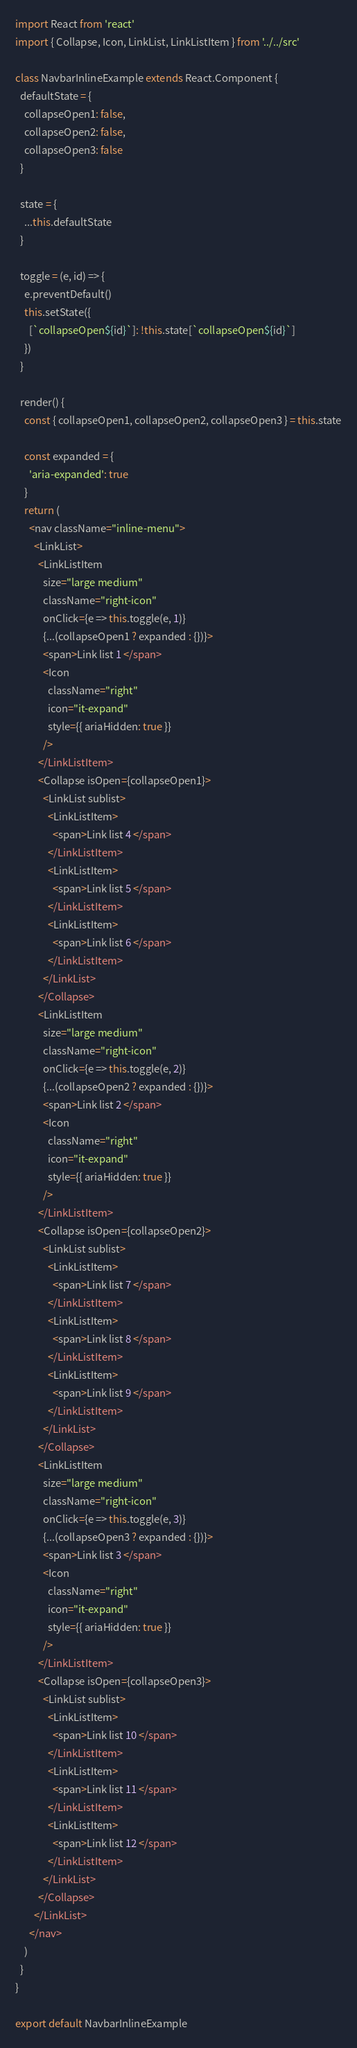Convert code to text. <code><loc_0><loc_0><loc_500><loc_500><_JavaScript_>import React from 'react'
import { Collapse, Icon, LinkList, LinkListItem } from '../../src'

class NavbarInlineExample extends React.Component {
  defaultState = {
    collapseOpen1: false,
    collapseOpen2: false,
    collapseOpen3: false
  }

  state = {
    ...this.defaultState
  }

  toggle = (e, id) => {
    e.preventDefault()
    this.setState({
      [`collapseOpen${id}`]: !this.state[`collapseOpen${id}`]
    })
  }

  render() {
    const { collapseOpen1, collapseOpen2, collapseOpen3 } = this.state

    const expanded = {
      'aria-expanded': true
    }
    return (
      <nav className="inline-menu">
        <LinkList>
          <LinkListItem
            size="large medium"
            className="right-icon"
            onClick={e => this.toggle(e, 1)}
            {...(collapseOpen1 ? expanded : {})}>
            <span>Link list 1 </span>
            <Icon
              className="right"
              icon="it-expand"
              style={{ ariaHidden: true }}
            />
          </LinkListItem>
          <Collapse isOpen={collapseOpen1}>
            <LinkList sublist>
              <LinkListItem>
                <span>Link list 4 </span>
              </LinkListItem>
              <LinkListItem>
                <span>Link list 5 </span>
              </LinkListItem>
              <LinkListItem>
                <span>Link list 6 </span>
              </LinkListItem>
            </LinkList>
          </Collapse>
          <LinkListItem
            size="large medium"
            className="right-icon"
            onClick={e => this.toggle(e, 2)}
            {...(collapseOpen2 ? expanded : {})}>
            <span>Link list 2 </span>
            <Icon
              className="right"
              icon="it-expand"
              style={{ ariaHidden: true }}
            />
          </LinkListItem>
          <Collapse isOpen={collapseOpen2}>
            <LinkList sublist>
              <LinkListItem>
                <span>Link list 7 </span>
              </LinkListItem>
              <LinkListItem>
                <span>Link list 8 </span>
              </LinkListItem>
              <LinkListItem>
                <span>Link list 9 </span>
              </LinkListItem>
            </LinkList>
          </Collapse>
          <LinkListItem
            size="large medium"
            className="right-icon"
            onClick={e => this.toggle(e, 3)}
            {...(collapseOpen3 ? expanded : {})}>
            <span>Link list 3 </span>
            <Icon
              className="right"
              icon="it-expand"
              style={{ ariaHidden: true }}
            />
          </LinkListItem>
          <Collapse isOpen={collapseOpen3}>
            <LinkList sublist>
              <LinkListItem>
                <span>Link list 10 </span>
              </LinkListItem>
              <LinkListItem>
                <span>Link list 11 </span>
              </LinkListItem>
              <LinkListItem>
                <span>Link list 12 </span>
              </LinkListItem>
            </LinkList>
          </Collapse>
        </LinkList>
      </nav>
    )
  }
}

export default NavbarInlineExample
</code> 